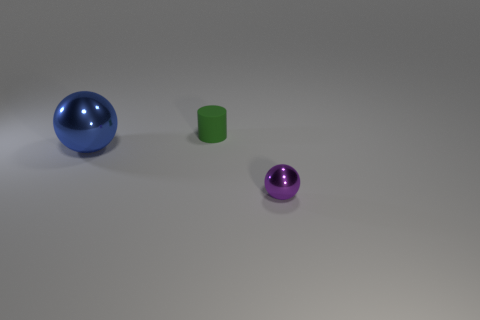Are there any other things that have the same color as the small metallic object?
Your answer should be compact. No. Are there an equal number of purple balls that are behind the large blue sphere and tiny green matte cylinders right of the tiny green cylinder?
Your answer should be very brief. Yes. Are there more tiny shiny spheres that are in front of the big metallic thing than tiny gray metallic cylinders?
Ensure brevity in your answer.  Yes. How many things are either small objects that are behind the tiny sphere or blue things?
Offer a very short reply. 2. What number of small purple balls are made of the same material as the blue sphere?
Offer a very short reply. 1. Are there any other purple metallic things of the same shape as the big shiny object?
Your answer should be very brief. Yes. The other thing that is the same size as the green matte object is what shape?
Provide a succinct answer. Sphere. How many small cylinders are in front of the metal sphere to the right of the blue metal thing?
Make the answer very short. 0. What is the size of the object that is in front of the tiny green rubber thing and on the left side of the purple metal ball?
Give a very brief answer. Large. Is there a purple thing that has the same size as the purple ball?
Provide a short and direct response. No. 